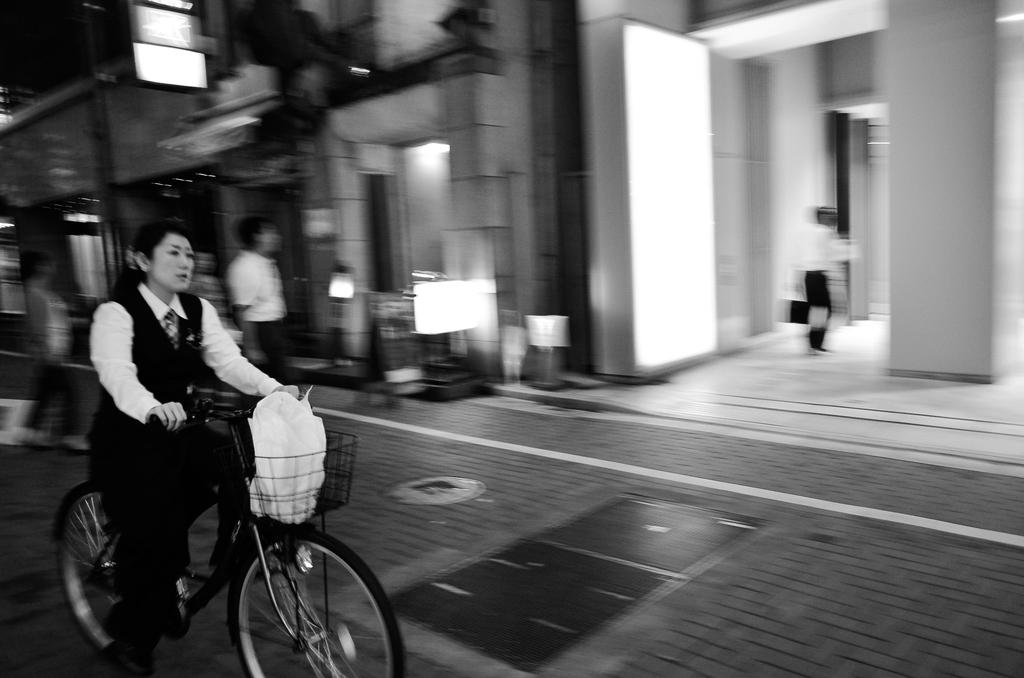What is the woman in the image doing? The woman is riding a bicycle in the image. What is the man in the image doing? One man is walking into a building, while another man is standing in the image. What can be seen in the background of the image? There is a hoarding in the image. How many brains can be seen in the image? There are no brains visible in the image. Are there any sisters in the image? The provided facts do not mention any sisters, so we cannot determine if there are any in the image. 